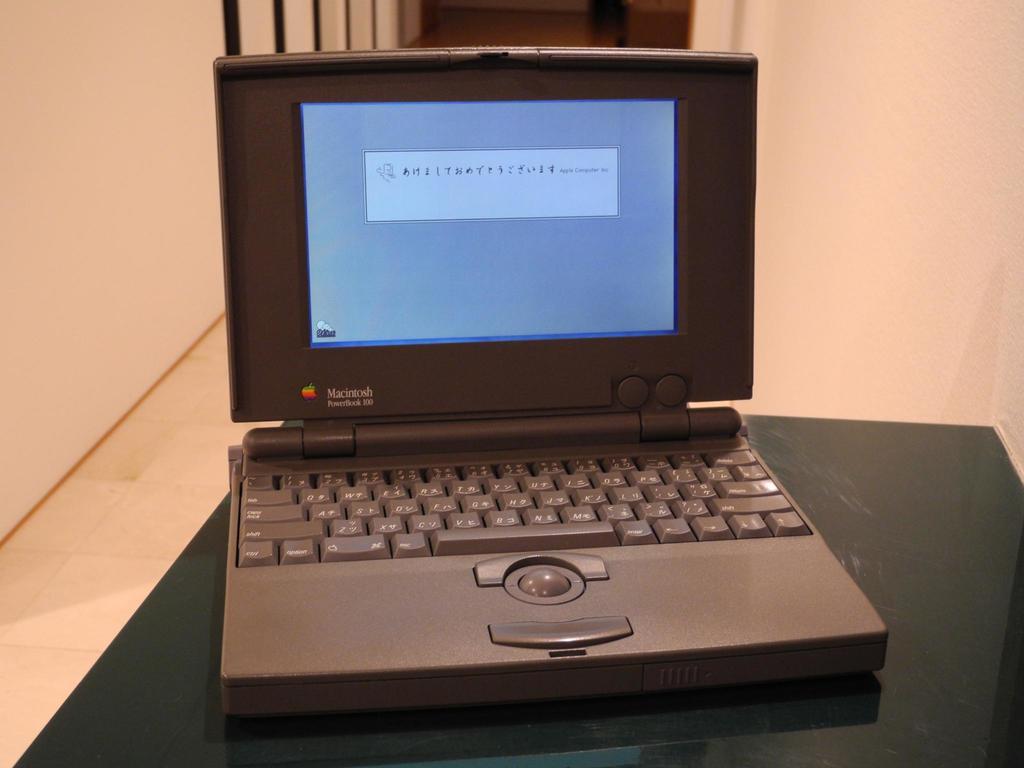What brand of computer?
Offer a very short reply. Macintosh. What colour is this laptop?
Keep it short and to the point. Answering does not require reading text in the image. 